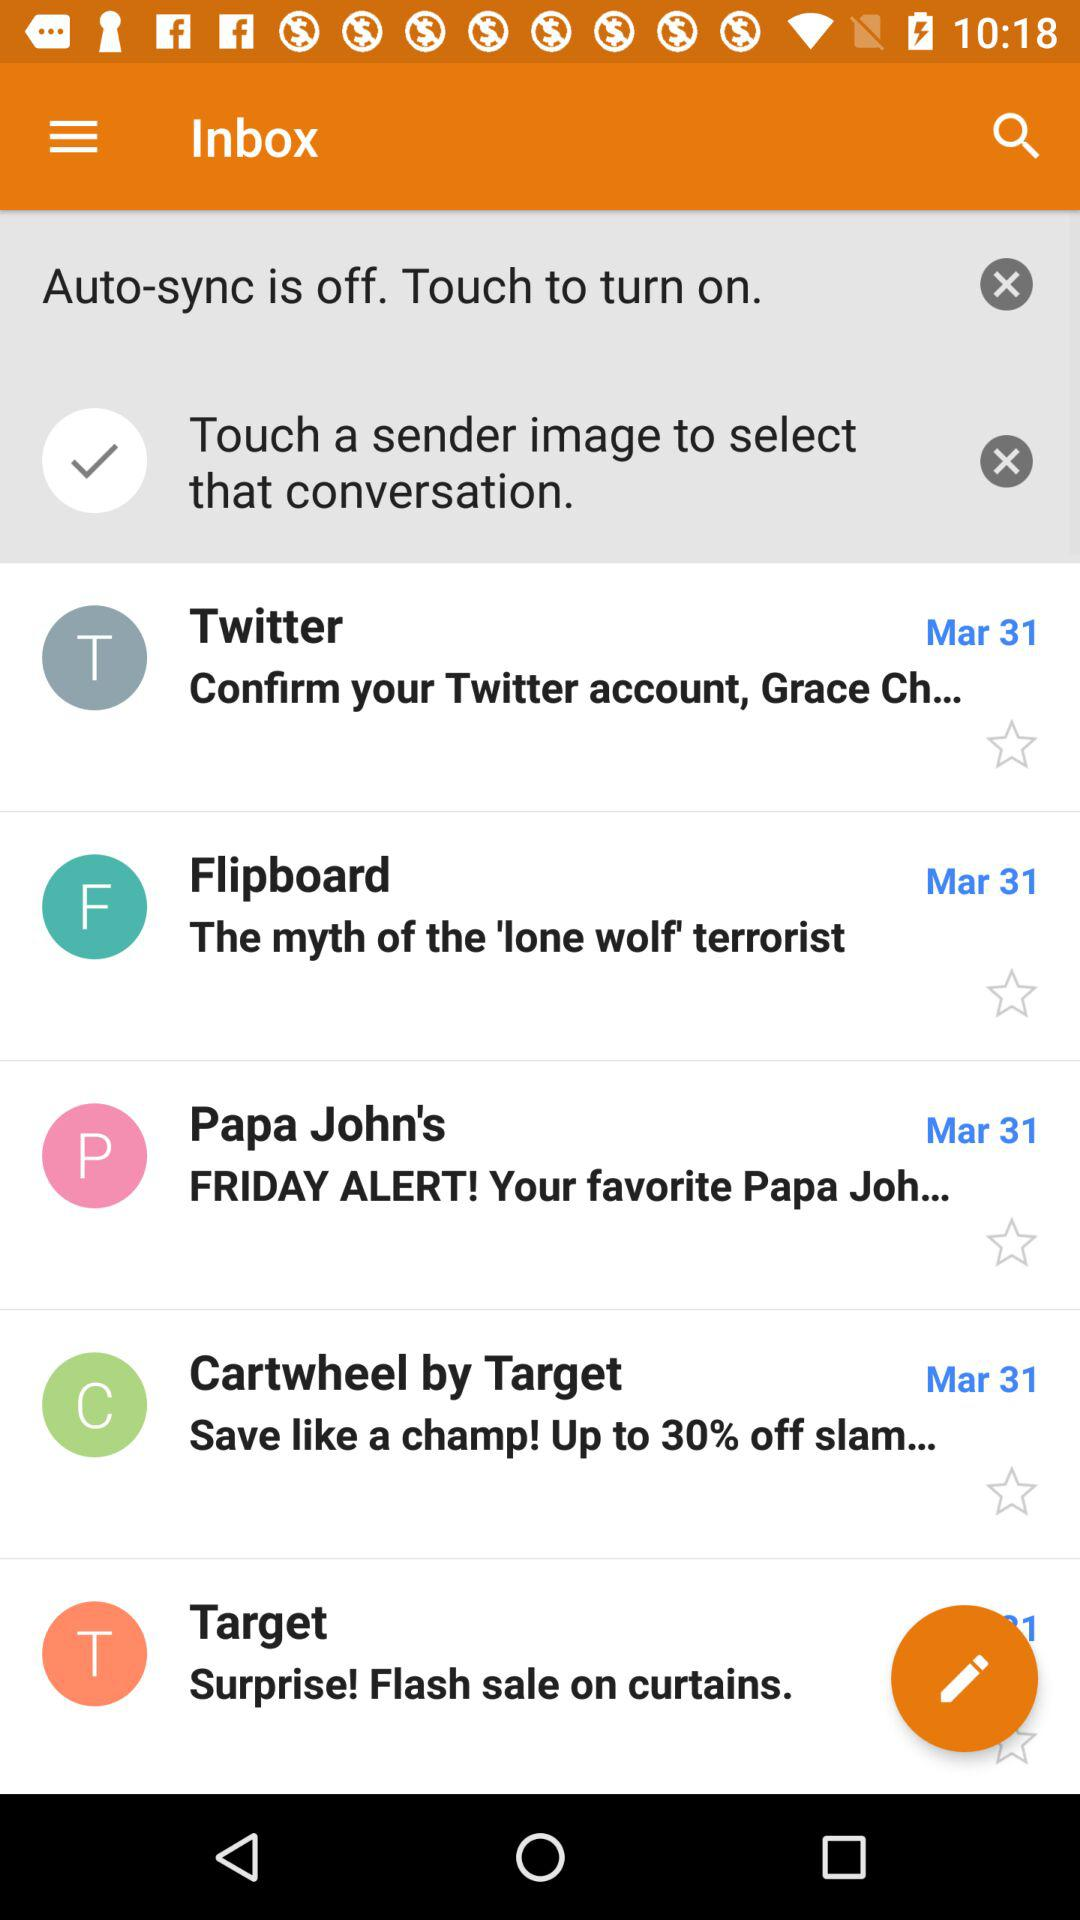What is the date of the message from Papa John's? The date of the message from Papa John's is March 31. 